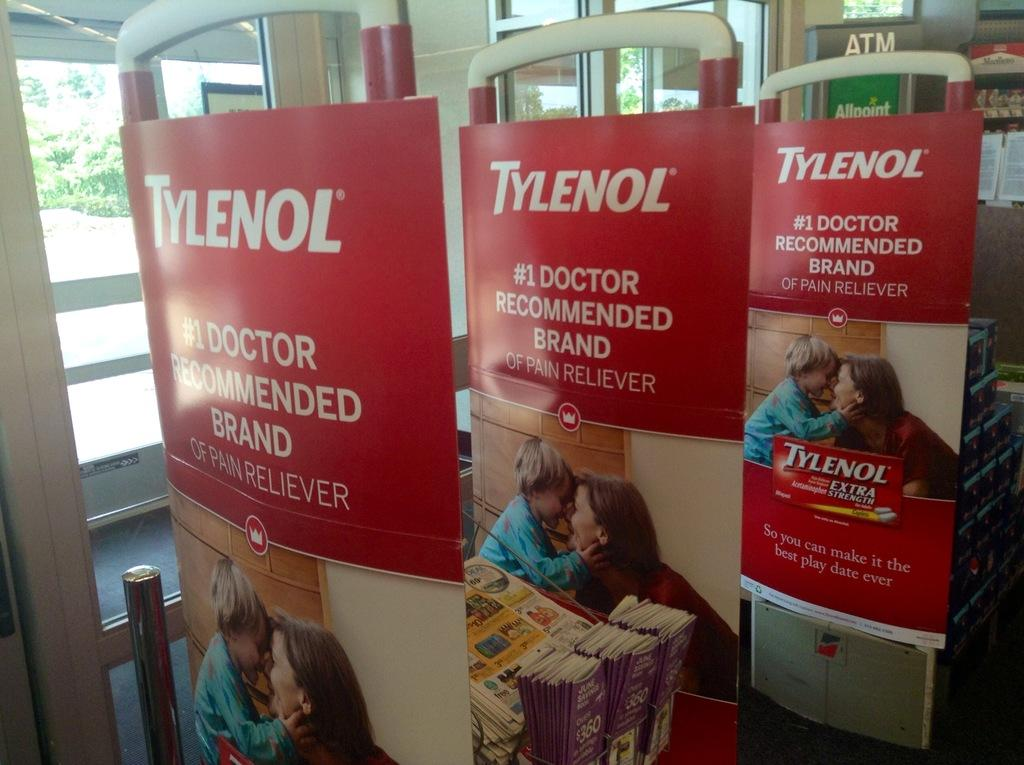<image>
Render a clear and concise summary of the photo. Three adverts in red for Tylenol, the painkiller. 